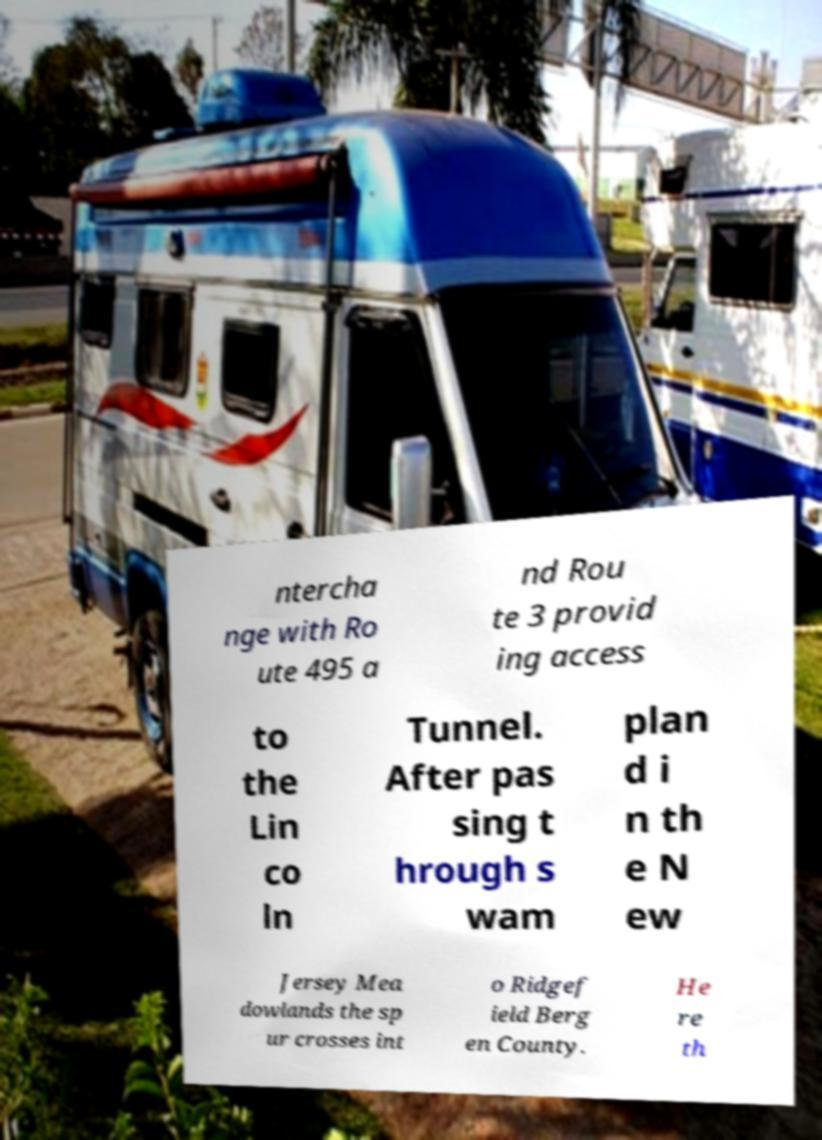Please identify and transcribe the text found in this image. ntercha nge with Ro ute 495 a nd Rou te 3 provid ing access to the Lin co ln Tunnel. After pas sing t hrough s wam plan d i n th e N ew Jersey Mea dowlands the sp ur crosses int o Ridgef ield Berg en County. He re th 